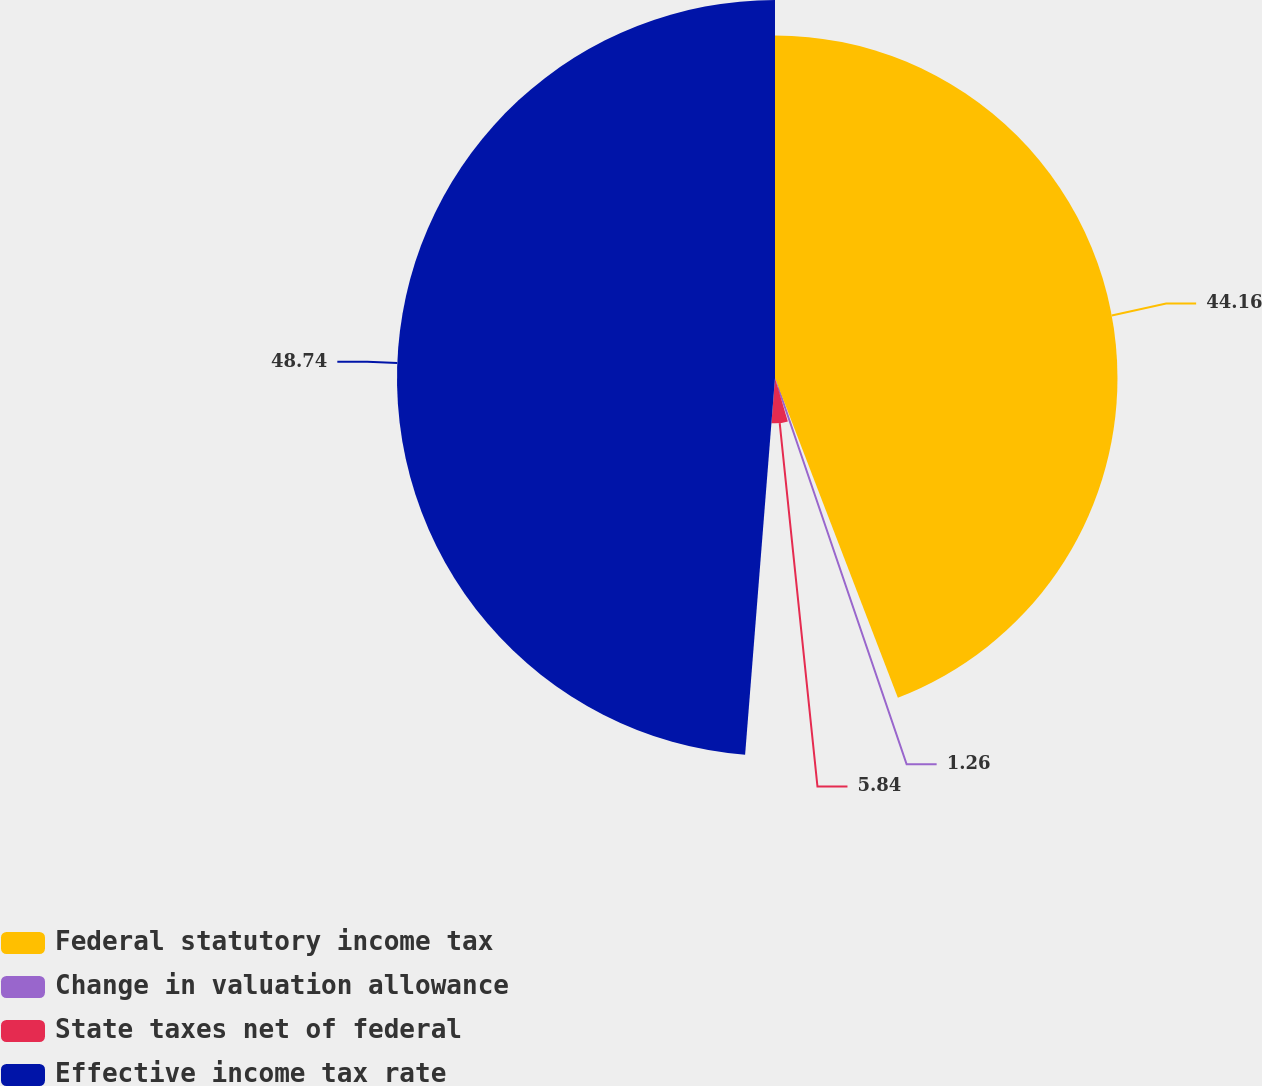<chart> <loc_0><loc_0><loc_500><loc_500><pie_chart><fcel>Federal statutory income tax<fcel>Change in valuation allowance<fcel>State taxes net of federal<fcel>Effective income tax rate<nl><fcel>44.16%<fcel>1.26%<fcel>5.84%<fcel>48.74%<nl></chart> 